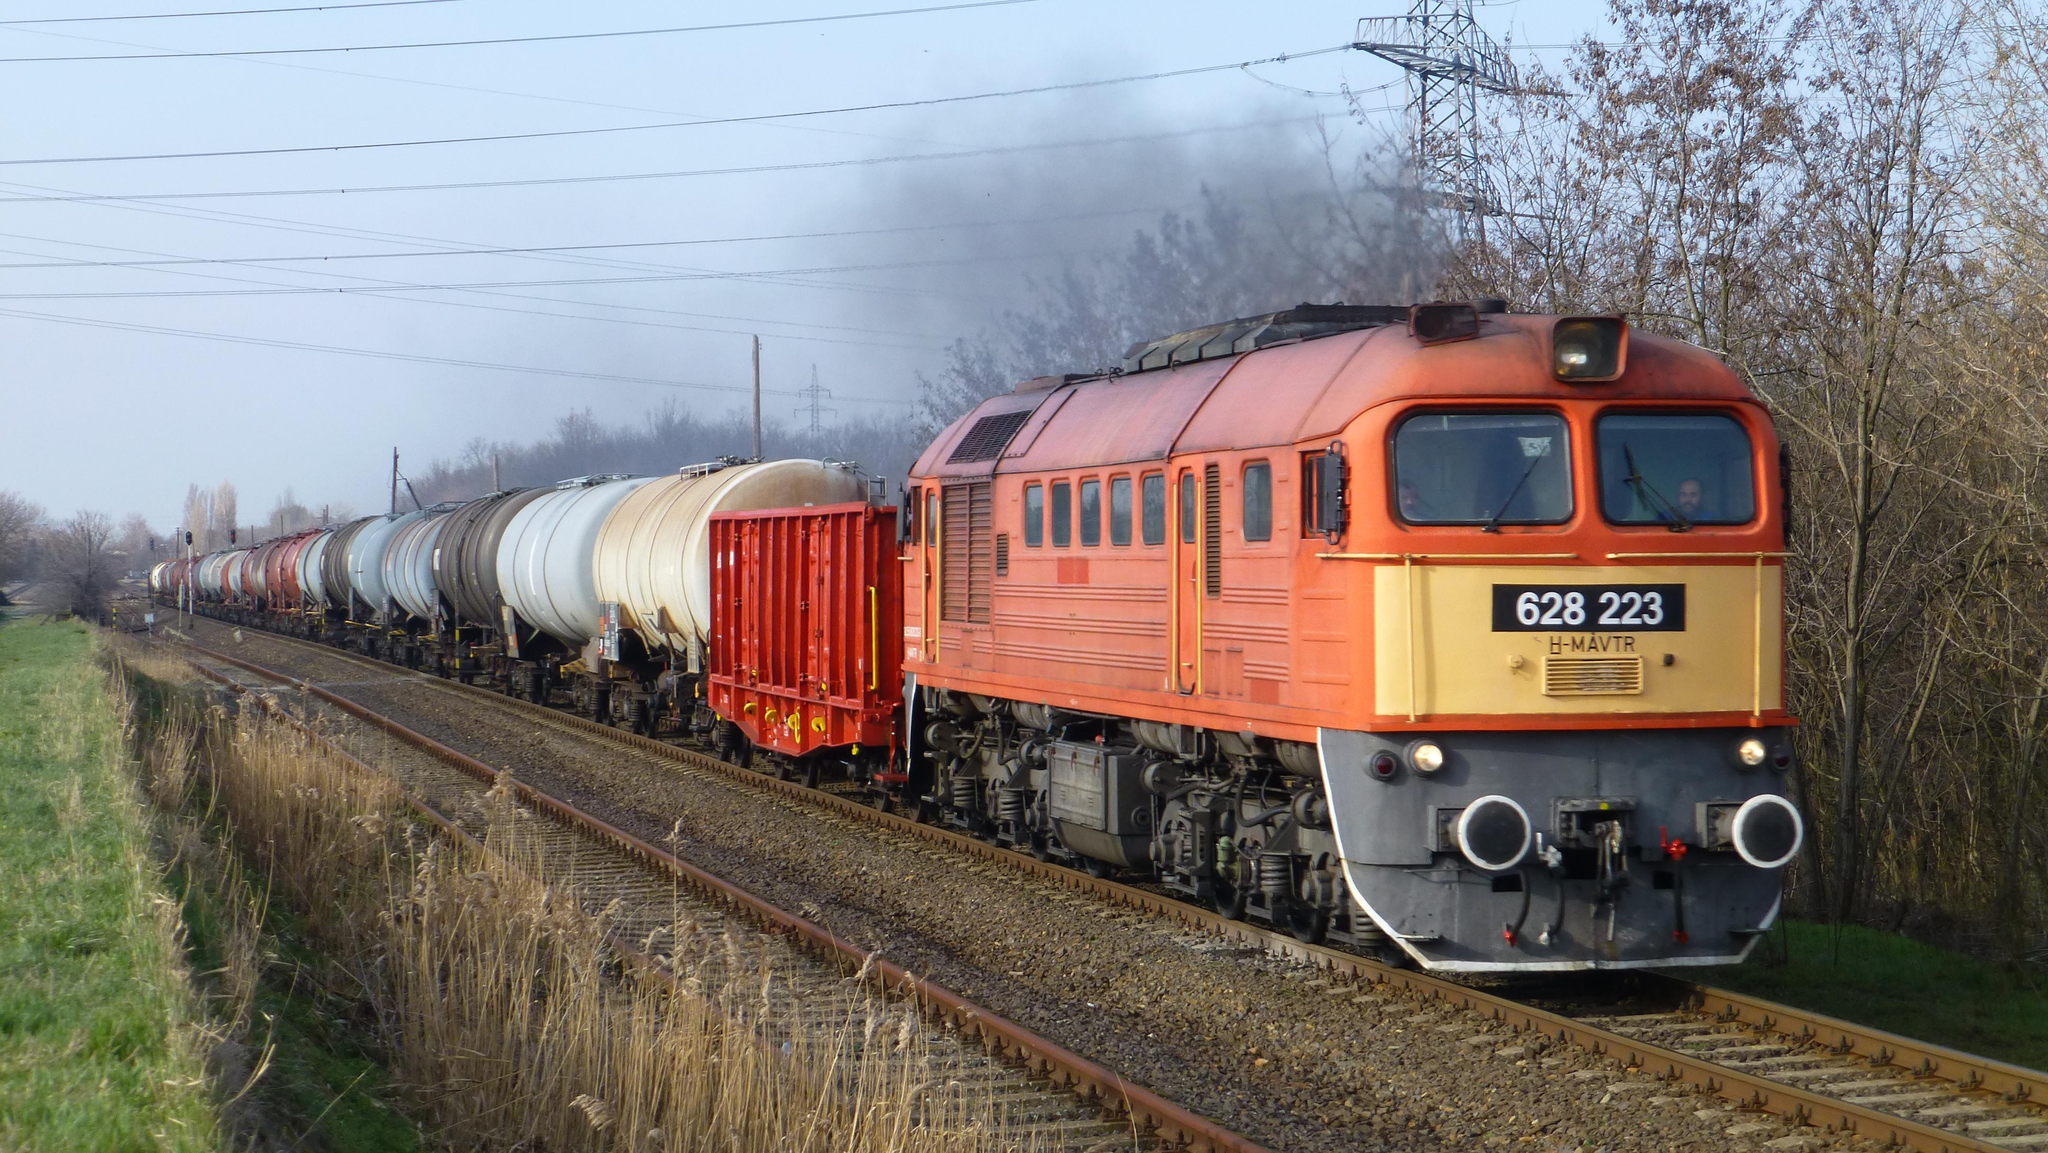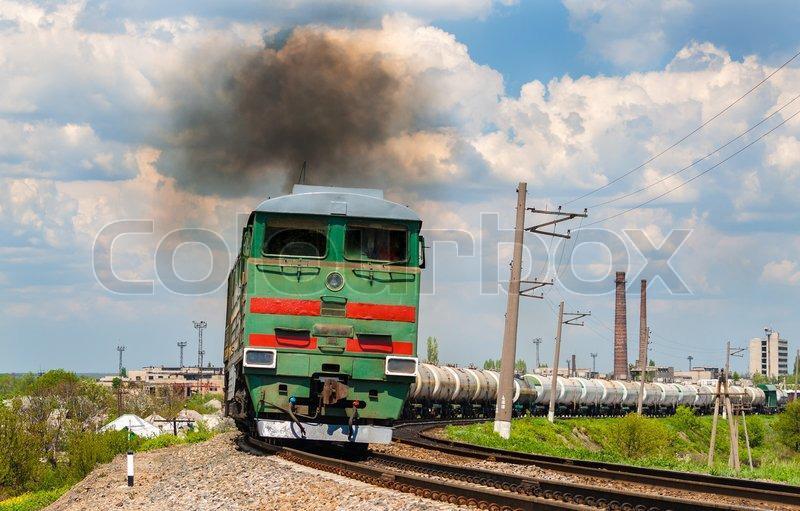The first image is the image on the left, the second image is the image on the right. For the images displayed, is the sentence "the right side image has a train heading to the left direction" factually correct? Answer yes or no. No. 